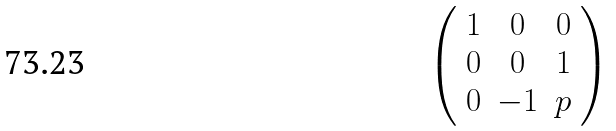<formula> <loc_0><loc_0><loc_500><loc_500>\left ( \begin{array} { c c c } 1 & 0 & 0 \\ 0 & 0 & 1 \\ 0 & - 1 & p \end{array} \right )</formula> 